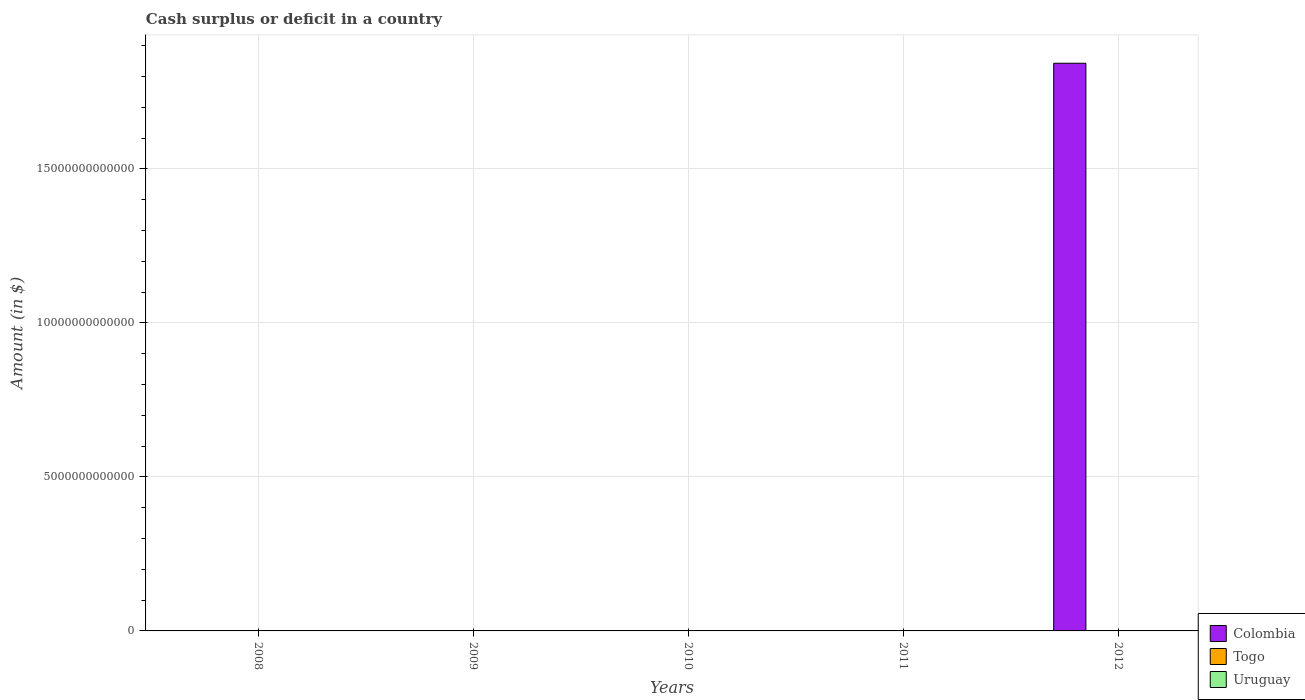What is the amount of cash surplus or deficit in Uruguay in 2012?
Your response must be concise. 0. Across all years, what is the maximum amount of cash surplus or deficit in Togo?
Keep it short and to the point. 9.09e+09. What is the total amount of cash surplus or deficit in Togo in the graph?
Make the answer very short. 1.29e+1. What is the difference between the amount of cash surplus or deficit in Togo in 2008 and the amount of cash surplus or deficit in Uruguay in 2012?
Provide a succinct answer. 3.82e+09. What is the average amount of cash surplus or deficit in Togo per year?
Offer a very short reply. 2.58e+09. What is the ratio of the amount of cash surplus or deficit in Togo in 2008 to that in 2010?
Keep it short and to the point. 0.42. What is the difference between the highest and the lowest amount of cash surplus or deficit in Togo?
Provide a succinct answer. 9.09e+09. In how many years, is the amount of cash surplus or deficit in Colombia greater than the average amount of cash surplus or deficit in Colombia taken over all years?
Keep it short and to the point. 1. How many bars are there?
Your answer should be compact. 3. What is the difference between two consecutive major ticks on the Y-axis?
Provide a succinct answer. 5.00e+12. Are the values on the major ticks of Y-axis written in scientific E-notation?
Make the answer very short. No. Does the graph contain any zero values?
Your response must be concise. Yes. Does the graph contain grids?
Provide a short and direct response. Yes. Where does the legend appear in the graph?
Your response must be concise. Bottom right. How many legend labels are there?
Provide a short and direct response. 3. How are the legend labels stacked?
Your answer should be very brief. Vertical. What is the title of the graph?
Provide a short and direct response. Cash surplus or deficit in a country. Does "Palau" appear as one of the legend labels in the graph?
Offer a very short reply. No. What is the label or title of the Y-axis?
Offer a terse response. Amount (in $). What is the Amount (in $) in Togo in 2008?
Provide a succinct answer. 3.82e+09. What is the Amount (in $) of Uruguay in 2008?
Offer a very short reply. 0. What is the Amount (in $) in Togo in 2009?
Make the answer very short. 0. What is the Amount (in $) in Togo in 2010?
Make the answer very short. 9.09e+09. What is the Amount (in $) of Colombia in 2011?
Give a very brief answer. 0. What is the Amount (in $) in Togo in 2011?
Your response must be concise. 0. What is the Amount (in $) in Colombia in 2012?
Make the answer very short. 1.84e+13. Across all years, what is the maximum Amount (in $) in Colombia?
Give a very brief answer. 1.84e+13. Across all years, what is the maximum Amount (in $) of Togo?
Your response must be concise. 9.09e+09. Across all years, what is the minimum Amount (in $) of Togo?
Offer a very short reply. 0. What is the total Amount (in $) of Colombia in the graph?
Your answer should be very brief. 1.84e+13. What is the total Amount (in $) in Togo in the graph?
Your answer should be compact. 1.29e+1. What is the total Amount (in $) in Uruguay in the graph?
Provide a short and direct response. 0. What is the difference between the Amount (in $) in Togo in 2008 and that in 2010?
Your answer should be compact. -5.28e+09. What is the average Amount (in $) in Colombia per year?
Ensure brevity in your answer.  3.69e+12. What is the average Amount (in $) in Togo per year?
Your answer should be very brief. 2.58e+09. What is the ratio of the Amount (in $) of Togo in 2008 to that in 2010?
Make the answer very short. 0.42. What is the difference between the highest and the lowest Amount (in $) of Colombia?
Offer a terse response. 1.84e+13. What is the difference between the highest and the lowest Amount (in $) of Togo?
Provide a short and direct response. 9.09e+09. 